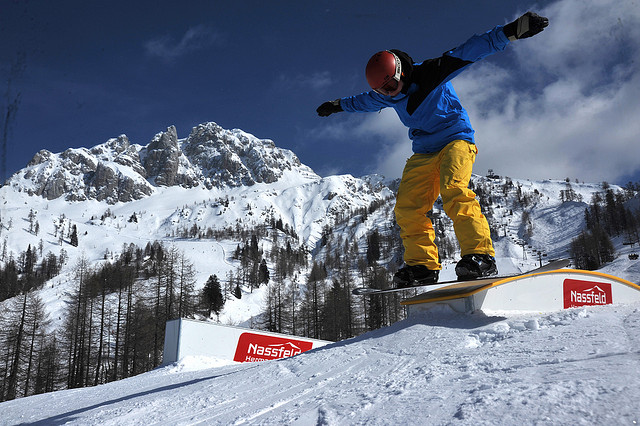If a film were made about the snowboarder's journey, what would be the central theme? If a film were made about the snowboarder's journey, the central theme would likely revolve around perseverance in the face of adversity and the quest for self-discovery. Through the challenges of mastering new tricks, overcoming the harsh elements, and navigating the rugged landscape, the snowboarder's journey would mirror a deeper, metaphorical quest for personal growth and fulfillment. The majestic mountains and the serene, snowy setting would serve as a backdrop for this tale of courage, resilience, and the unyielding human spirit's drive to reach new heights. 